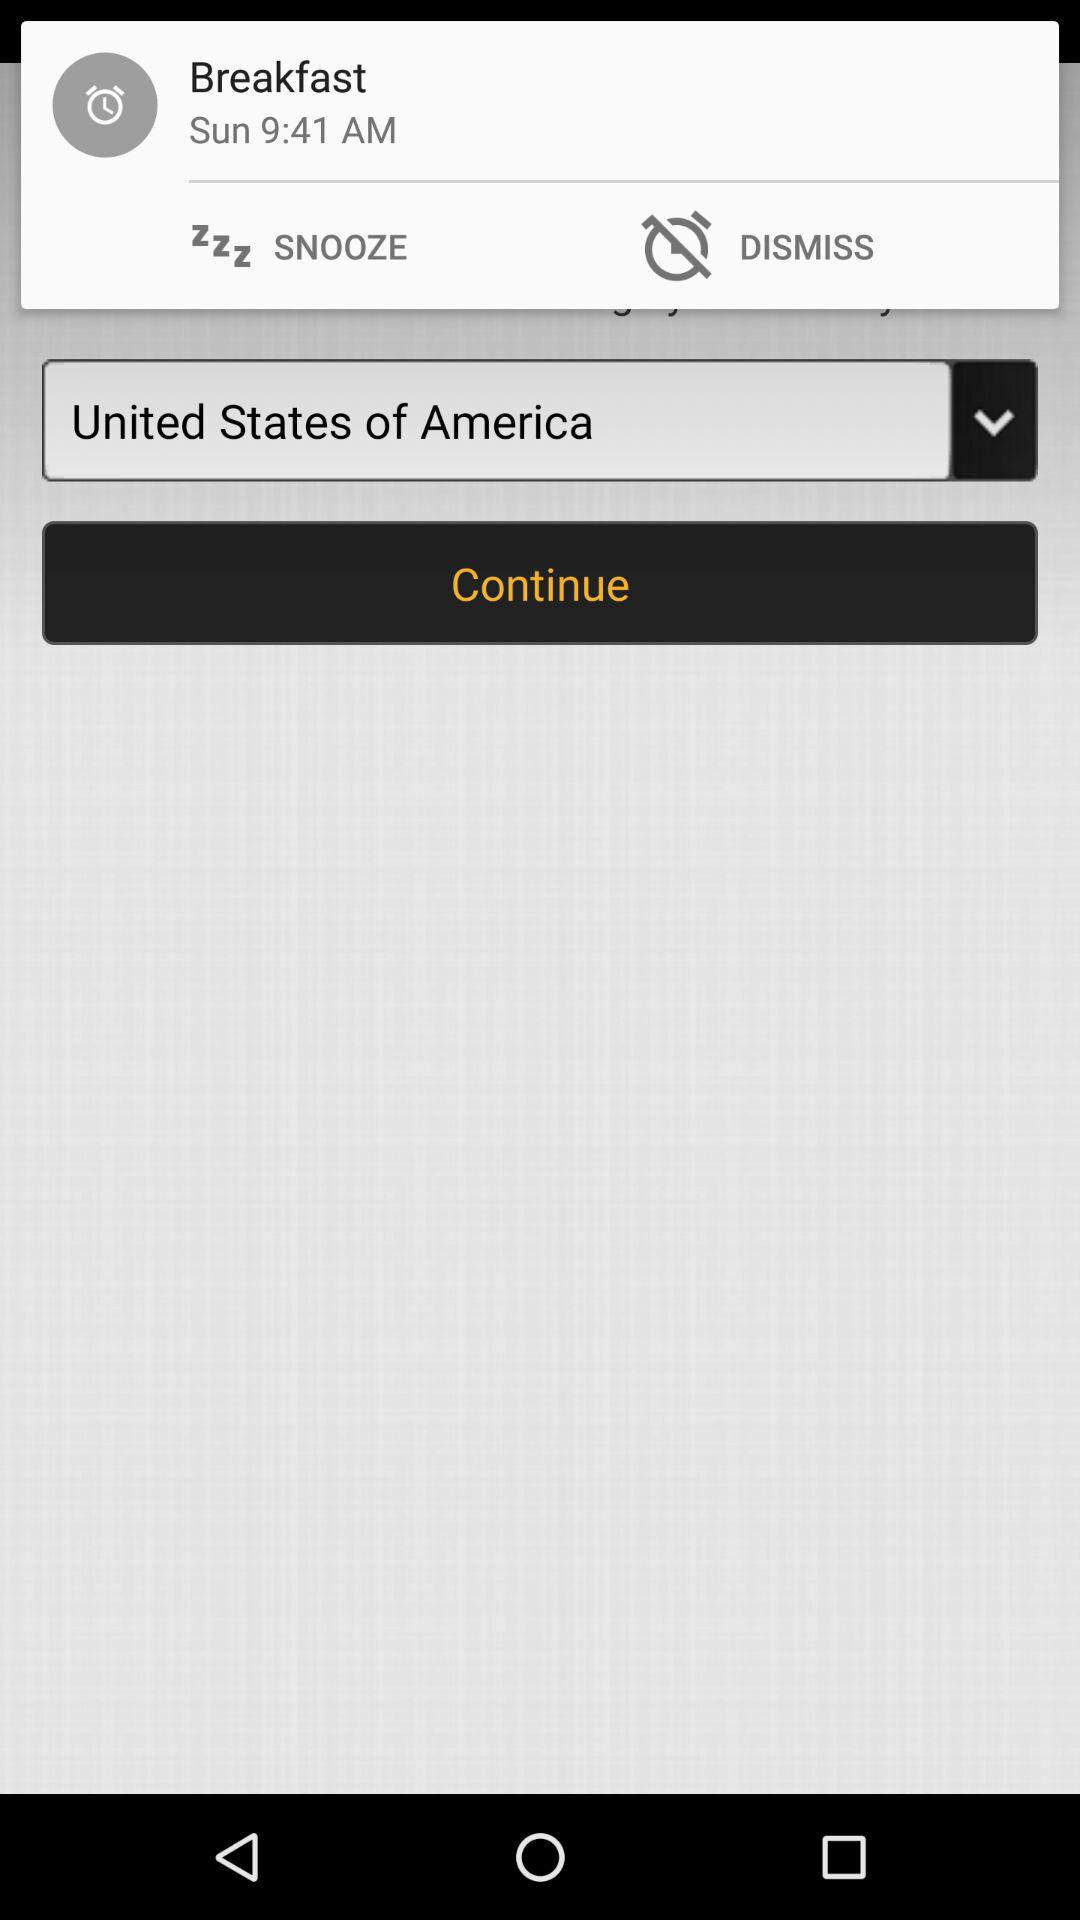What is the alarm time? The alarm time is 9:41 AM. 